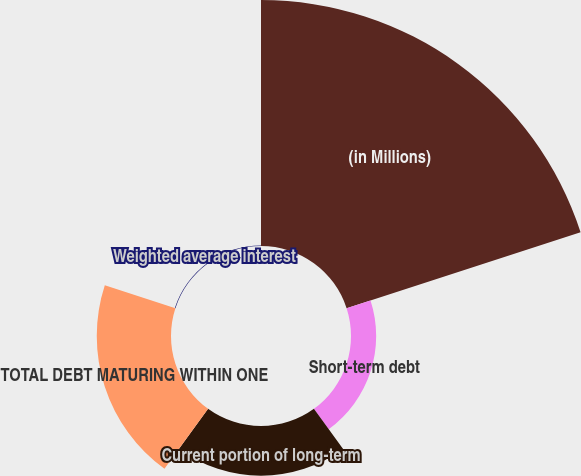Convert chart. <chart><loc_0><loc_0><loc_500><loc_500><pie_chart><fcel>(in Millions)<fcel>Short-term debt<fcel>Current portion of long-term<fcel>TOTAL DEBT MATURING WITHIN ONE<fcel>Weighted average interest<nl><fcel>62.17%<fcel>6.36%<fcel>12.56%<fcel>18.76%<fcel>0.15%<nl></chart> 